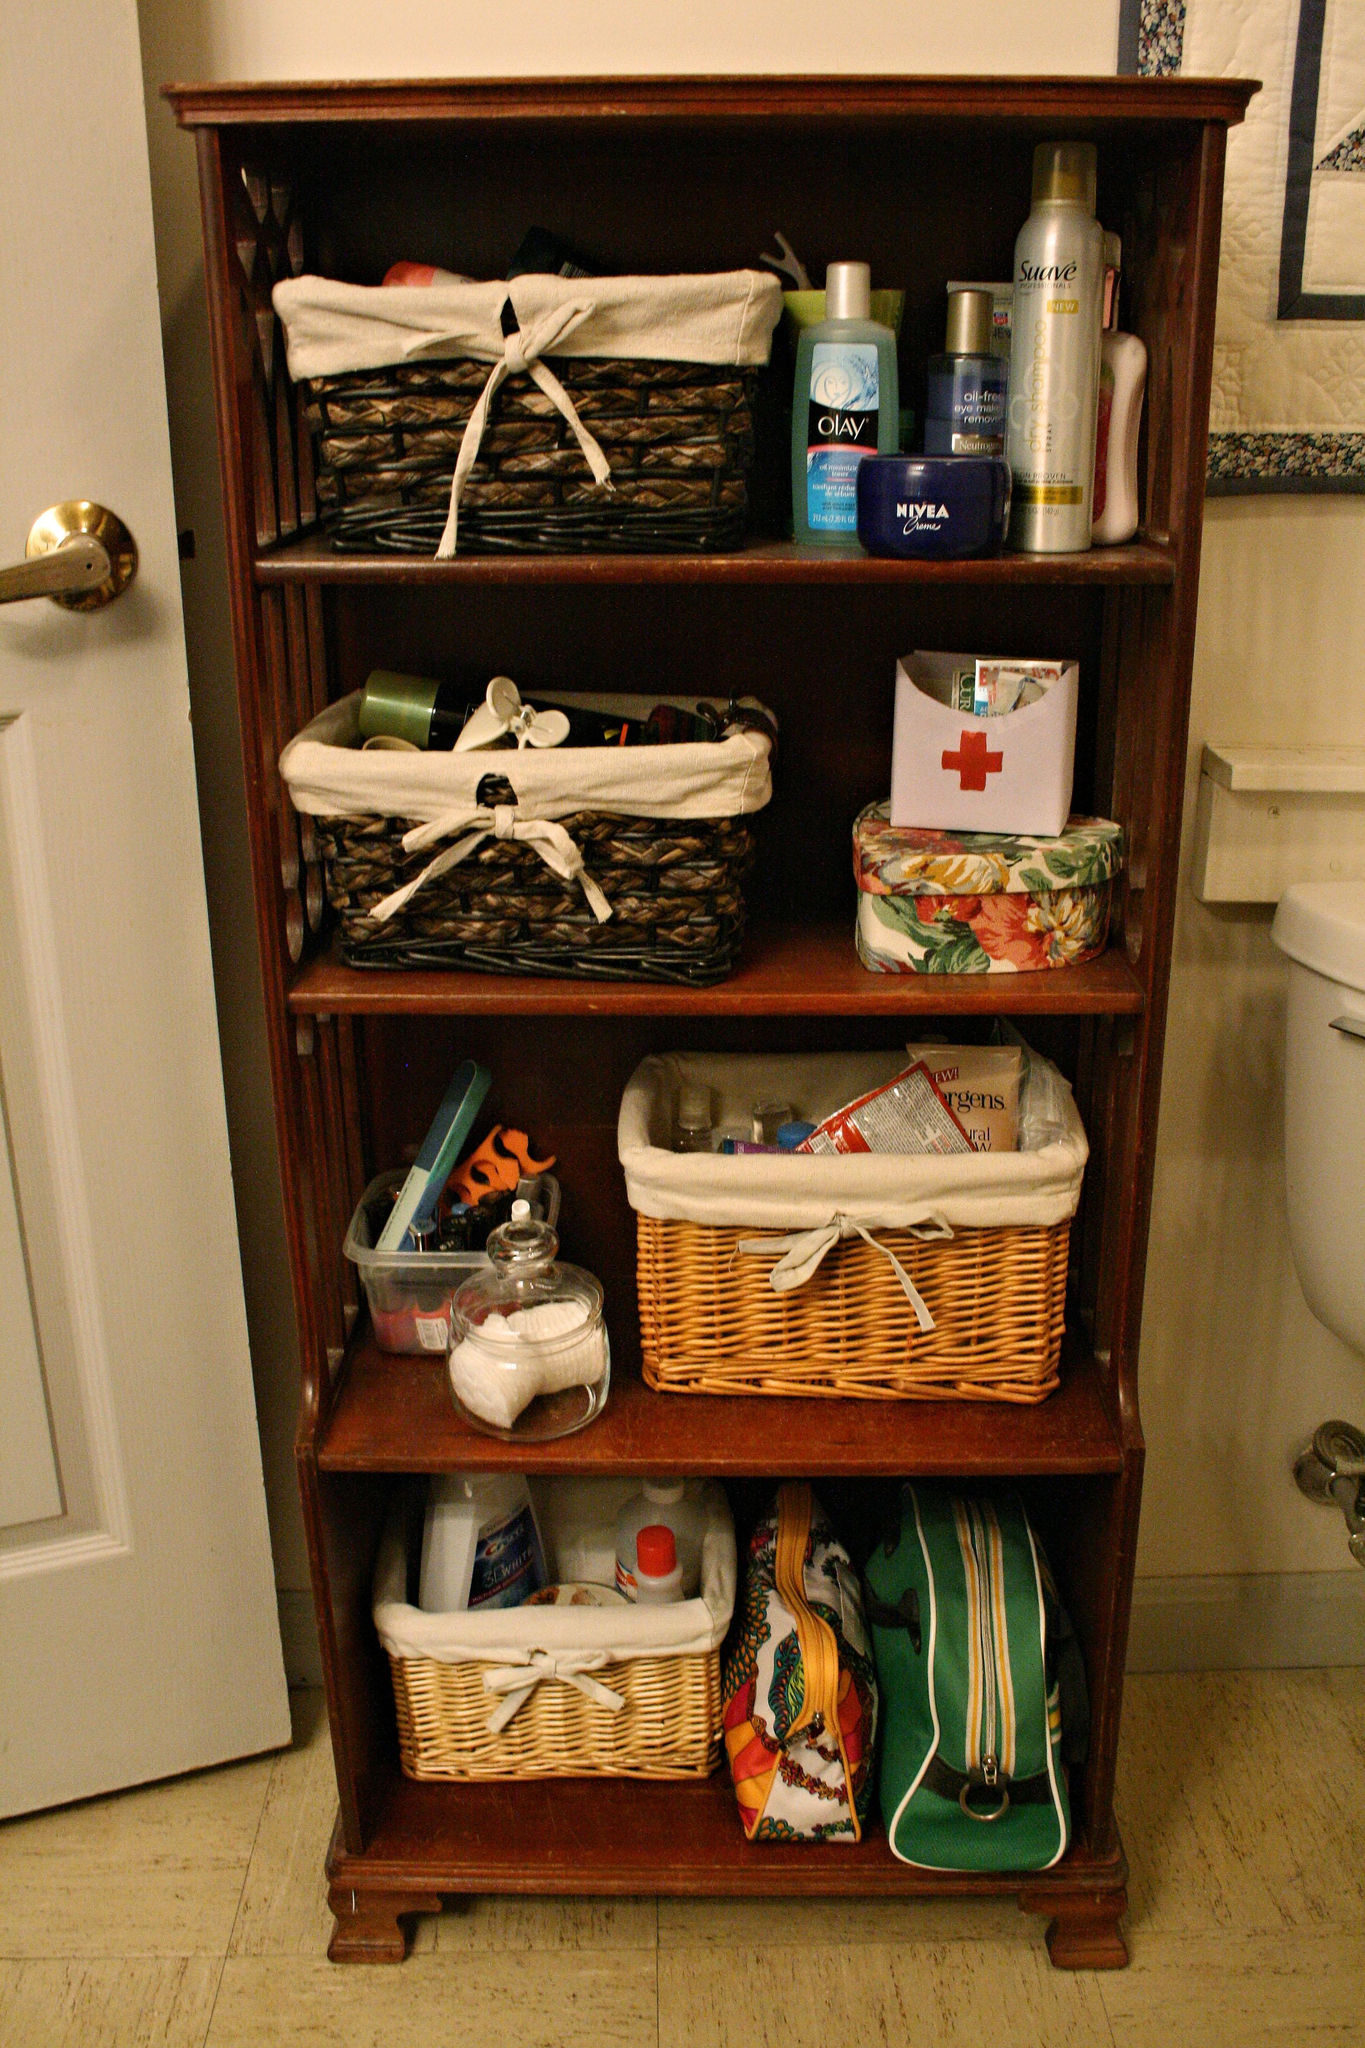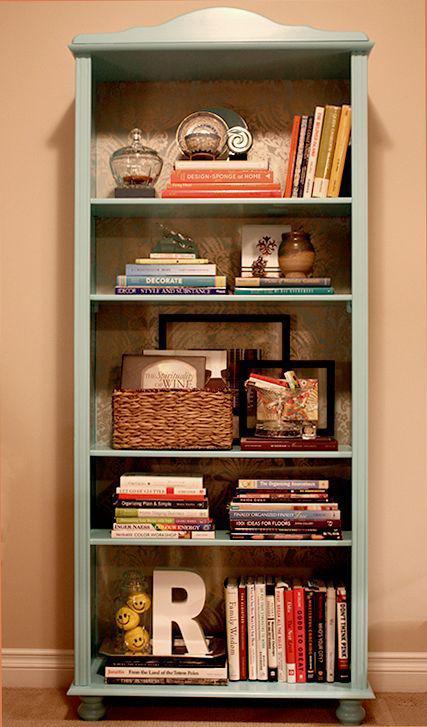The first image is the image on the left, the second image is the image on the right. Examine the images to the left and right. Is the description "Each bookshelf is freestanding." accurate? Answer yes or no. Yes. The first image is the image on the left, the second image is the image on the right. Given the left and right images, does the statement "There are at least three bookshelves made in to one that take up the wall of a room." hold true? Answer yes or no. No. 